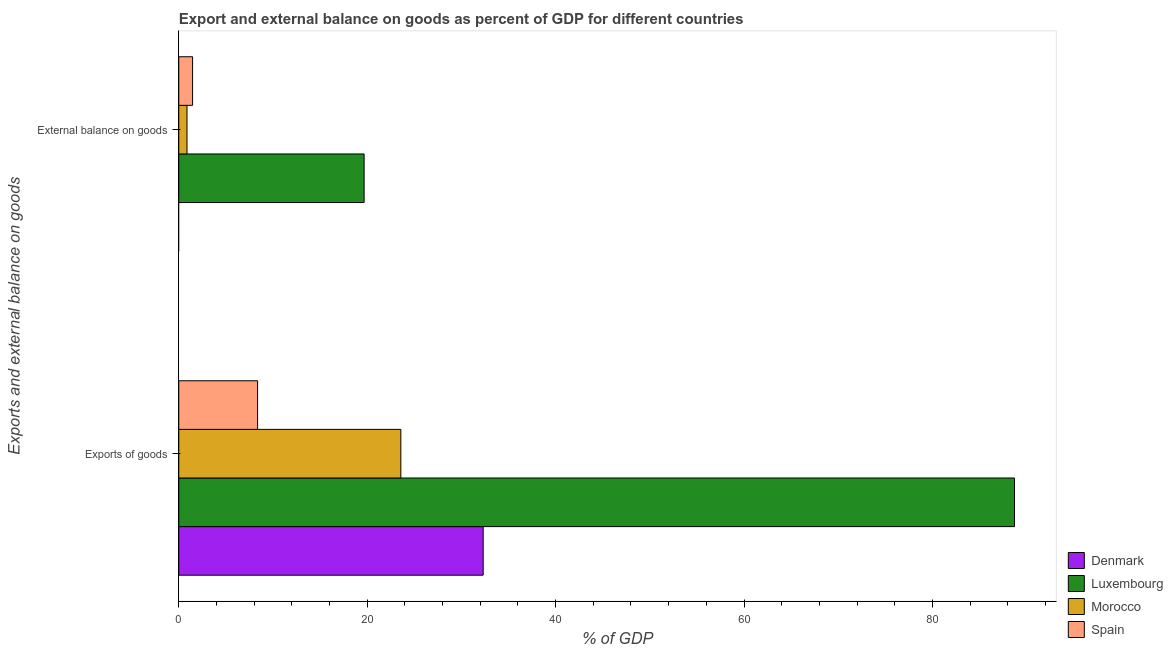How many groups of bars are there?
Offer a terse response. 2. Are the number of bars per tick equal to the number of legend labels?
Your answer should be compact. No. Are the number of bars on each tick of the Y-axis equal?
Give a very brief answer. No. What is the label of the 2nd group of bars from the top?
Give a very brief answer. Exports of goods. What is the external balance on goods as percentage of gdp in Morocco?
Your answer should be compact. 0.87. Across all countries, what is the maximum external balance on goods as percentage of gdp?
Offer a terse response. 19.67. Across all countries, what is the minimum export of goods as percentage of gdp?
Give a very brief answer. 8.37. In which country was the export of goods as percentage of gdp maximum?
Keep it short and to the point. Luxembourg. What is the total external balance on goods as percentage of gdp in the graph?
Offer a terse response. 22.01. What is the difference between the external balance on goods as percentage of gdp in Spain and that in Luxembourg?
Provide a succinct answer. -18.21. What is the difference between the export of goods as percentage of gdp in Spain and the external balance on goods as percentage of gdp in Luxembourg?
Your answer should be very brief. -11.31. What is the average export of goods as percentage of gdp per country?
Make the answer very short. 38.24. What is the difference between the external balance on goods as percentage of gdp and export of goods as percentage of gdp in Spain?
Give a very brief answer. -6.9. What is the ratio of the external balance on goods as percentage of gdp in Luxembourg to that in Morocco?
Ensure brevity in your answer.  22.54. Is the export of goods as percentage of gdp in Morocco less than that in Spain?
Offer a very short reply. No. In how many countries, is the external balance on goods as percentage of gdp greater than the average external balance on goods as percentage of gdp taken over all countries?
Your response must be concise. 1. Are all the bars in the graph horizontal?
Ensure brevity in your answer.  Yes. Are the values on the major ticks of X-axis written in scientific E-notation?
Keep it short and to the point. No. Does the graph contain any zero values?
Offer a very short reply. Yes. Where does the legend appear in the graph?
Keep it short and to the point. Bottom right. How many legend labels are there?
Your answer should be compact. 4. How are the legend labels stacked?
Offer a terse response. Vertical. What is the title of the graph?
Your answer should be compact. Export and external balance on goods as percent of GDP for different countries. Does "Malawi" appear as one of the legend labels in the graph?
Offer a terse response. No. What is the label or title of the X-axis?
Keep it short and to the point. % of GDP. What is the label or title of the Y-axis?
Ensure brevity in your answer.  Exports and external balance on goods. What is the % of GDP in Denmark in Exports of goods?
Ensure brevity in your answer.  32.31. What is the % of GDP of Luxembourg in Exports of goods?
Your answer should be compact. 88.71. What is the % of GDP in Morocco in Exports of goods?
Give a very brief answer. 23.57. What is the % of GDP in Spain in Exports of goods?
Your answer should be very brief. 8.37. What is the % of GDP of Denmark in External balance on goods?
Your answer should be compact. 0. What is the % of GDP of Luxembourg in External balance on goods?
Provide a succinct answer. 19.67. What is the % of GDP of Morocco in External balance on goods?
Offer a terse response. 0.87. What is the % of GDP of Spain in External balance on goods?
Ensure brevity in your answer.  1.47. Across all Exports and external balance on goods, what is the maximum % of GDP of Denmark?
Keep it short and to the point. 32.31. Across all Exports and external balance on goods, what is the maximum % of GDP of Luxembourg?
Provide a succinct answer. 88.71. Across all Exports and external balance on goods, what is the maximum % of GDP of Morocco?
Your response must be concise. 23.57. Across all Exports and external balance on goods, what is the maximum % of GDP in Spain?
Offer a very short reply. 8.37. Across all Exports and external balance on goods, what is the minimum % of GDP of Luxembourg?
Your answer should be very brief. 19.67. Across all Exports and external balance on goods, what is the minimum % of GDP in Morocco?
Keep it short and to the point. 0.87. Across all Exports and external balance on goods, what is the minimum % of GDP of Spain?
Make the answer very short. 1.47. What is the total % of GDP in Denmark in the graph?
Offer a terse response. 32.31. What is the total % of GDP of Luxembourg in the graph?
Offer a very short reply. 108.39. What is the total % of GDP of Morocco in the graph?
Your answer should be very brief. 24.44. What is the total % of GDP in Spain in the graph?
Keep it short and to the point. 9.83. What is the difference between the % of GDP of Luxembourg in Exports of goods and that in External balance on goods?
Keep it short and to the point. 69.04. What is the difference between the % of GDP of Morocco in Exports of goods and that in External balance on goods?
Keep it short and to the point. 22.7. What is the difference between the % of GDP in Spain in Exports of goods and that in External balance on goods?
Ensure brevity in your answer.  6.9. What is the difference between the % of GDP in Denmark in Exports of goods and the % of GDP in Luxembourg in External balance on goods?
Provide a short and direct response. 12.64. What is the difference between the % of GDP of Denmark in Exports of goods and the % of GDP of Morocco in External balance on goods?
Provide a short and direct response. 31.44. What is the difference between the % of GDP in Denmark in Exports of goods and the % of GDP in Spain in External balance on goods?
Make the answer very short. 30.85. What is the difference between the % of GDP of Luxembourg in Exports of goods and the % of GDP of Morocco in External balance on goods?
Make the answer very short. 87.84. What is the difference between the % of GDP in Luxembourg in Exports of goods and the % of GDP in Spain in External balance on goods?
Your response must be concise. 87.25. What is the difference between the % of GDP in Morocco in Exports of goods and the % of GDP in Spain in External balance on goods?
Provide a short and direct response. 22.11. What is the average % of GDP in Denmark per Exports and external balance on goods?
Ensure brevity in your answer.  16.16. What is the average % of GDP in Luxembourg per Exports and external balance on goods?
Offer a terse response. 54.19. What is the average % of GDP in Morocco per Exports and external balance on goods?
Your answer should be very brief. 12.22. What is the average % of GDP in Spain per Exports and external balance on goods?
Give a very brief answer. 4.92. What is the difference between the % of GDP in Denmark and % of GDP in Luxembourg in Exports of goods?
Make the answer very short. -56.4. What is the difference between the % of GDP of Denmark and % of GDP of Morocco in Exports of goods?
Provide a succinct answer. 8.74. What is the difference between the % of GDP in Denmark and % of GDP in Spain in Exports of goods?
Provide a short and direct response. 23.94. What is the difference between the % of GDP in Luxembourg and % of GDP in Morocco in Exports of goods?
Offer a very short reply. 65.14. What is the difference between the % of GDP in Luxembourg and % of GDP in Spain in Exports of goods?
Your response must be concise. 80.34. What is the difference between the % of GDP in Morocco and % of GDP in Spain in Exports of goods?
Provide a succinct answer. 15.2. What is the difference between the % of GDP of Luxembourg and % of GDP of Morocco in External balance on goods?
Ensure brevity in your answer.  18.8. What is the difference between the % of GDP of Luxembourg and % of GDP of Spain in External balance on goods?
Give a very brief answer. 18.21. What is the difference between the % of GDP of Morocco and % of GDP of Spain in External balance on goods?
Offer a terse response. -0.59. What is the ratio of the % of GDP of Luxembourg in Exports of goods to that in External balance on goods?
Make the answer very short. 4.51. What is the ratio of the % of GDP in Spain in Exports of goods to that in External balance on goods?
Provide a short and direct response. 5.71. What is the difference between the highest and the second highest % of GDP of Luxembourg?
Your answer should be compact. 69.04. What is the difference between the highest and the second highest % of GDP of Morocco?
Provide a short and direct response. 22.7. What is the difference between the highest and the second highest % of GDP in Spain?
Offer a terse response. 6.9. What is the difference between the highest and the lowest % of GDP of Denmark?
Your answer should be very brief. 32.31. What is the difference between the highest and the lowest % of GDP of Luxembourg?
Make the answer very short. 69.04. What is the difference between the highest and the lowest % of GDP of Morocco?
Offer a very short reply. 22.7. What is the difference between the highest and the lowest % of GDP in Spain?
Offer a very short reply. 6.9. 